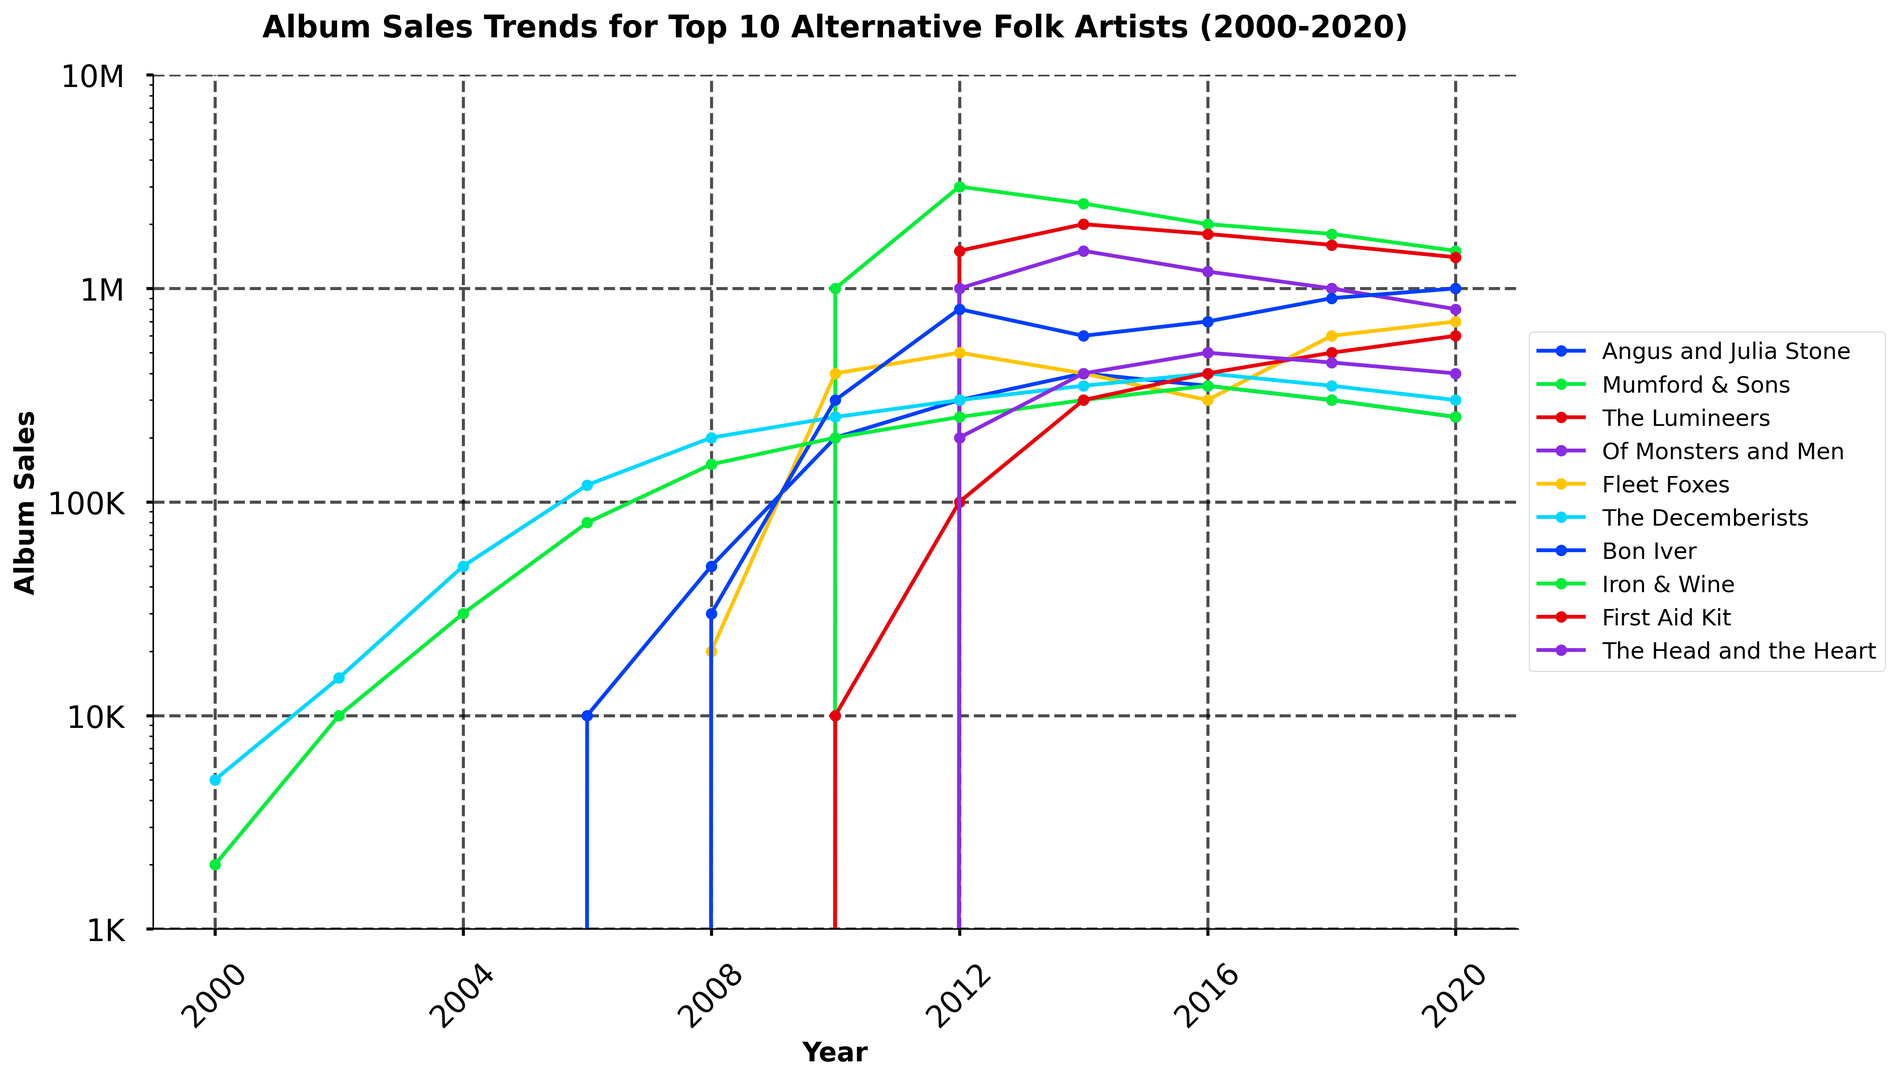What year did Mumford & Sons achieve their highest album sales? Refer to the line labeled for Mumford & Sons on the chart and identify the peak point on the time axis, which corresponds to the year when their sales were the highest.
Answer: 2012 From 2000 to 2020, which artist had the most consistent album sales? Look for the artist whose sales line has minimal fluctuations and maintains a relatively consistent trend throughout the years.
Answer: The Decemberists How do the album sales of Angus and Julia Stone in 2010 compare to their sales in 2020? Find the points on the chart corresponding to Angus and Julia Stone for the years 2010 and 2020, note their values, and compare them.
Answer: 2010 is higher Between 2008 and 2014, did The Lumineers or Mumford & Sons have a larger increase in album sales? Calculate the increase for The Lumineers (from 0 in 2008 to 2,000,000 in 2014) and for Mumford & Sons (from 0 in 2008 to 2,500,000 in 2014) and compare the differences.
Answer: Mumford & Sons What is the total album sales of Bon Iver for the entire period from 2000 to 2020? Sum up all the album sales values for Bon Iver from each year listed in the chart.
Answer: 3,400,000 Which artist had the largest drop in album sales from 2018 to 2020? Check the difference in album sales from 2018 to 2020 for each artist and identify the one with the highest negative value.
Answer: Mumford & Sons In which year did the album sales of Fleet Foxes start to show a notable increase? Locate the point on Fleet Foxes' sales line where there is a marked upward trend in album sales.
Answer: 2008 Compare the album sales trends of Iron & Wine and First Aid Kit from 2000 to 2020. Which artist had generally higher sales? Trace the sales lines for both artists and examine which one generally stays higher over the years.
Answer: Iron & Wine What is the combined album sales of The Head and the Heart and First Aid Kit in 2020? Add the album sales figures of The Head and the Heart and First Aid Kit for the year 2020.
Answer: 1,000,000 Among all artists, whose sales in 2016 were the closest to 1,000,000? Identify the sales value closest to 1,000,000 for any artist in 2016 and determine whose sales line it corresponds to.
Answer: The Lumineers 